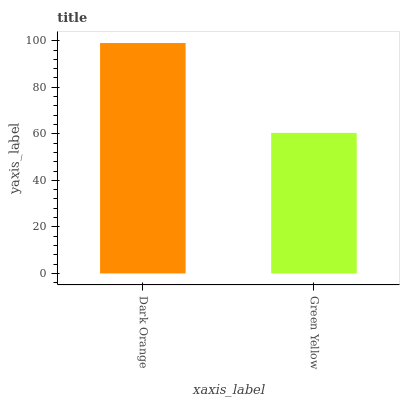Is Green Yellow the minimum?
Answer yes or no. Yes. Is Dark Orange the maximum?
Answer yes or no. Yes. Is Green Yellow the maximum?
Answer yes or no. No. Is Dark Orange greater than Green Yellow?
Answer yes or no. Yes. Is Green Yellow less than Dark Orange?
Answer yes or no. Yes. Is Green Yellow greater than Dark Orange?
Answer yes or no. No. Is Dark Orange less than Green Yellow?
Answer yes or no. No. Is Dark Orange the high median?
Answer yes or no. Yes. Is Green Yellow the low median?
Answer yes or no. Yes. Is Green Yellow the high median?
Answer yes or no. No. Is Dark Orange the low median?
Answer yes or no. No. 